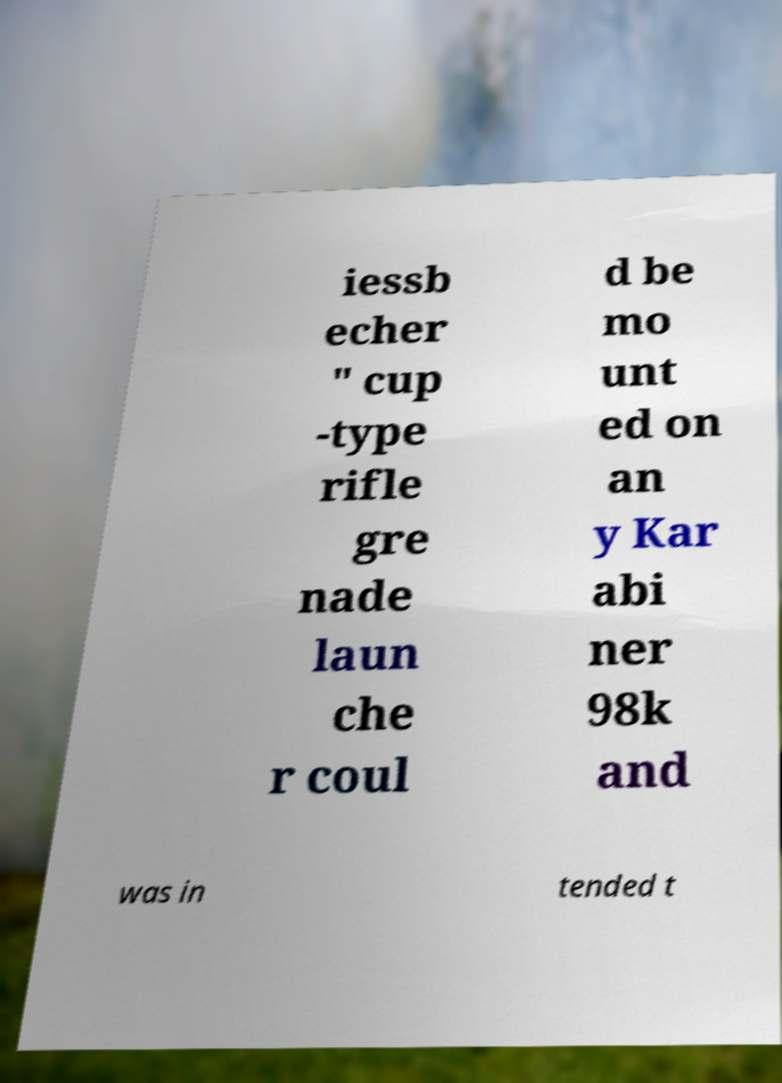Could you assist in decoding the text presented in this image and type it out clearly? iessb echer " cup -type rifle gre nade laun che r coul d be mo unt ed on an y Kar abi ner 98k and was in tended t 